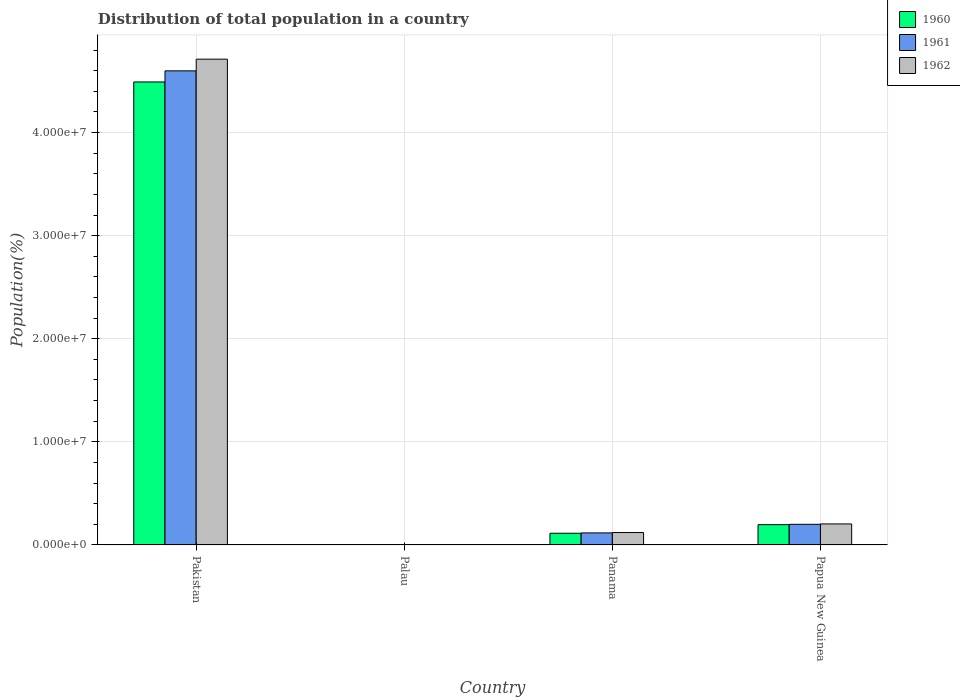Are the number of bars per tick equal to the number of legend labels?
Provide a succinct answer. Yes. What is the label of the 3rd group of bars from the left?
Keep it short and to the point. Panama. In how many cases, is the number of bars for a given country not equal to the number of legend labels?
Give a very brief answer. 0. What is the population of in 1961 in Pakistan?
Your answer should be very brief. 4.60e+07. Across all countries, what is the maximum population of in 1962?
Ensure brevity in your answer.  4.71e+07. Across all countries, what is the minimum population of in 1961?
Make the answer very short. 9901. In which country was the population of in 1961 maximum?
Give a very brief answer. Pakistan. In which country was the population of in 1960 minimum?
Your answer should be compact. Palau. What is the total population of in 1961 in the graph?
Make the answer very short. 4.92e+07. What is the difference between the population of in 1962 in Panama and that in Papua New Guinea?
Your answer should be very brief. -8.35e+05. What is the difference between the population of in 1960 in Palau and the population of in 1962 in Pakistan?
Your answer should be very brief. -4.71e+07. What is the average population of in 1960 per country?
Your response must be concise. 1.20e+07. What is the difference between the population of of/in 1960 and population of of/in 1961 in Panama?
Make the answer very short. -3.41e+04. In how many countries, is the population of in 1961 greater than 14000000 %?
Your response must be concise. 1. What is the ratio of the population of in 1960 in Panama to that in Papua New Guinea?
Your response must be concise. 0.58. Is the population of in 1960 in Pakistan less than that in Papua New Guinea?
Offer a terse response. No. What is the difference between the highest and the second highest population of in 1960?
Your answer should be compact. 4.38e+07. What is the difference between the highest and the lowest population of in 1962?
Offer a terse response. 4.71e+07. Is the sum of the population of in 1961 in Pakistan and Panama greater than the maximum population of in 1962 across all countries?
Your response must be concise. Yes. What does the 1st bar from the left in Panama represents?
Offer a terse response. 1960. What does the 3rd bar from the right in Pakistan represents?
Provide a succinct answer. 1960. Are the values on the major ticks of Y-axis written in scientific E-notation?
Provide a succinct answer. Yes. What is the title of the graph?
Your response must be concise. Distribution of total population in a country. Does "2007" appear as one of the legend labels in the graph?
Provide a short and direct response. No. What is the label or title of the X-axis?
Provide a short and direct response. Country. What is the label or title of the Y-axis?
Provide a succinct answer. Population(%). What is the Population(%) in 1960 in Pakistan?
Provide a short and direct response. 4.49e+07. What is the Population(%) of 1961 in Pakistan?
Ensure brevity in your answer.  4.60e+07. What is the Population(%) of 1962 in Pakistan?
Offer a very short reply. 4.71e+07. What is the Population(%) in 1960 in Palau?
Your response must be concise. 9638. What is the Population(%) of 1961 in Palau?
Ensure brevity in your answer.  9901. What is the Population(%) of 1962 in Palau?
Provide a succinct answer. 1.02e+04. What is the Population(%) in 1960 in Panama?
Offer a terse response. 1.13e+06. What is the Population(%) in 1961 in Panama?
Provide a succinct answer. 1.17e+06. What is the Population(%) in 1962 in Panama?
Make the answer very short. 1.20e+06. What is the Population(%) in 1960 in Papua New Guinea?
Ensure brevity in your answer.  1.97e+06. What is the Population(%) of 1961 in Papua New Guinea?
Provide a succinct answer. 2.00e+06. What is the Population(%) of 1962 in Papua New Guinea?
Provide a short and direct response. 2.04e+06. Across all countries, what is the maximum Population(%) in 1960?
Provide a succinct answer. 4.49e+07. Across all countries, what is the maximum Population(%) of 1961?
Offer a very short reply. 4.60e+07. Across all countries, what is the maximum Population(%) of 1962?
Provide a succinct answer. 4.71e+07. Across all countries, what is the minimum Population(%) in 1960?
Your answer should be compact. 9638. Across all countries, what is the minimum Population(%) of 1961?
Your answer should be very brief. 9901. Across all countries, what is the minimum Population(%) in 1962?
Ensure brevity in your answer.  1.02e+04. What is the total Population(%) of 1960 in the graph?
Give a very brief answer. 4.80e+07. What is the total Population(%) of 1961 in the graph?
Your answer should be very brief. 4.92e+07. What is the total Population(%) of 1962 in the graph?
Keep it short and to the point. 5.04e+07. What is the difference between the Population(%) in 1960 in Pakistan and that in Palau?
Offer a very short reply. 4.49e+07. What is the difference between the Population(%) of 1961 in Pakistan and that in Palau?
Your answer should be very brief. 4.60e+07. What is the difference between the Population(%) of 1962 in Pakistan and that in Palau?
Make the answer very short. 4.71e+07. What is the difference between the Population(%) of 1960 in Pakistan and that in Panama?
Offer a very short reply. 4.38e+07. What is the difference between the Population(%) of 1961 in Pakistan and that in Panama?
Make the answer very short. 4.48e+07. What is the difference between the Population(%) of 1962 in Pakistan and that in Panama?
Provide a succinct answer. 4.59e+07. What is the difference between the Population(%) in 1960 in Pakistan and that in Papua New Guinea?
Provide a succinct answer. 4.29e+07. What is the difference between the Population(%) in 1961 in Pakistan and that in Papua New Guinea?
Provide a short and direct response. 4.40e+07. What is the difference between the Population(%) in 1962 in Pakistan and that in Papua New Guinea?
Offer a very short reply. 4.51e+07. What is the difference between the Population(%) in 1960 in Palau and that in Panama?
Offer a terse response. -1.12e+06. What is the difference between the Population(%) of 1961 in Palau and that in Panama?
Provide a short and direct response. -1.16e+06. What is the difference between the Population(%) in 1962 in Palau and that in Panama?
Provide a short and direct response. -1.19e+06. What is the difference between the Population(%) of 1960 in Palau and that in Papua New Guinea?
Offer a very short reply. -1.96e+06. What is the difference between the Population(%) in 1961 in Palau and that in Papua New Guinea?
Provide a succinct answer. -1.99e+06. What is the difference between the Population(%) of 1962 in Palau and that in Papua New Guinea?
Your answer should be compact. -2.03e+06. What is the difference between the Population(%) in 1960 in Panama and that in Papua New Guinea?
Offer a terse response. -8.34e+05. What is the difference between the Population(%) of 1961 in Panama and that in Papua New Guinea?
Offer a very short reply. -8.34e+05. What is the difference between the Population(%) in 1962 in Panama and that in Papua New Guinea?
Provide a short and direct response. -8.35e+05. What is the difference between the Population(%) of 1960 in Pakistan and the Population(%) of 1961 in Palau?
Your answer should be very brief. 4.49e+07. What is the difference between the Population(%) of 1960 in Pakistan and the Population(%) of 1962 in Palau?
Offer a terse response. 4.49e+07. What is the difference between the Population(%) in 1961 in Pakistan and the Population(%) in 1962 in Palau?
Make the answer very short. 4.60e+07. What is the difference between the Population(%) in 1960 in Pakistan and the Population(%) in 1961 in Panama?
Offer a terse response. 4.37e+07. What is the difference between the Population(%) in 1960 in Pakistan and the Population(%) in 1962 in Panama?
Provide a succinct answer. 4.37e+07. What is the difference between the Population(%) in 1961 in Pakistan and the Population(%) in 1962 in Panama?
Provide a succinct answer. 4.48e+07. What is the difference between the Population(%) in 1960 in Pakistan and the Population(%) in 1961 in Papua New Guinea?
Your response must be concise. 4.29e+07. What is the difference between the Population(%) in 1960 in Pakistan and the Population(%) in 1962 in Papua New Guinea?
Offer a terse response. 4.29e+07. What is the difference between the Population(%) of 1961 in Pakistan and the Population(%) of 1962 in Papua New Guinea?
Keep it short and to the point. 4.40e+07. What is the difference between the Population(%) of 1960 in Palau and the Population(%) of 1961 in Panama?
Your answer should be very brief. -1.16e+06. What is the difference between the Population(%) in 1960 in Palau and the Population(%) in 1962 in Panama?
Offer a very short reply. -1.19e+06. What is the difference between the Population(%) of 1961 in Palau and the Population(%) of 1962 in Panama?
Offer a terse response. -1.19e+06. What is the difference between the Population(%) of 1960 in Palau and the Population(%) of 1961 in Papua New Guinea?
Your answer should be very brief. -1.99e+06. What is the difference between the Population(%) in 1960 in Palau and the Population(%) in 1962 in Papua New Guinea?
Offer a terse response. -2.03e+06. What is the difference between the Population(%) of 1961 in Palau and the Population(%) of 1962 in Papua New Guinea?
Your answer should be compact. -2.03e+06. What is the difference between the Population(%) in 1960 in Panama and the Population(%) in 1961 in Papua New Guinea?
Ensure brevity in your answer.  -8.68e+05. What is the difference between the Population(%) in 1960 in Panama and the Population(%) in 1962 in Papua New Guinea?
Keep it short and to the point. -9.04e+05. What is the difference between the Population(%) in 1961 in Panama and the Population(%) in 1962 in Papua New Guinea?
Make the answer very short. -8.70e+05. What is the average Population(%) in 1960 per country?
Your answer should be compact. 1.20e+07. What is the average Population(%) of 1961 per country?
Offer a very short reply. 1.23e+07. What is the average Population(%) in 1962 per country?
Provide a succinct answer. 1.26e+07. What is the difference between the Population(%) in 1960 and Population(%) in 1961 in Pakistan?
Offer a very short reply. -1.08e+06. What is the difference between the Population(%) of 1960 and Population(%) of 1962 in Pakistan?
Provide a short and direct response. -2.21e+06. What is the difference between the Population(%) in 1961 and Population(%) in 1962 in Pakistan?
Keep it short and to the point. -1.13e+06. What is the difference between the Population(%) of 1960 and Population(%) of 1961 in Palau?
Your answer should be very brief. -263. What is the difference between the Population(%) of 1960 and Population(%) of 1962 in Palau?
Your answer should be compact. -512. What is the difference between the Population(%) of 1961 and Population(%) of 1962 in Palau?
Make the answer very short. -249. What is the difference between the Population(%) in 1960 and Population(%) in 1961 in Panama?
Offer a very short reply. -3.41e+04. What is the difference between the Population(%) in 1960 and Population(%) in 1962 in Panama?
Provide a short and direct response. -6.94e+04. What is the difference between the Population(%) of 1961 and Population(%) of 1962 in Panama?
Your answer should be compact. -3.53e+04. What is the difference between the Population(%) in 1960 and Population(%) in 1961 in Papua New Guinea?
Ensure brevity in your answer.  -3.41e+04. What is the difference between the Population(%) in 1960 and Population(%) in 1962 in Papua New Guinea?
Ensure brevity in your answer.  -7.02e+04. What is the difference between the Population(%) of 1961 and Population(%) of 1962 in Papua New Guinea?
Provide a short and direct response. -3.61e+04. What is the ratio of the Population(%) of 1960 in Pakistan to that in Palau?
Keep it short and to the point. 4659.87. What is the ratio of the Population(%) in 1961 in Pakistan to that in Palau?
Ensure brevity in your answer.  4644.83. What is the ratio of the Population(%) of 1962 in Pakistan to that in Palau?
Offer a very short reply. 4642.65. What is the ratio of the Population(%) of 1960 in Pakistan to that in Panama?
Keep it short and to the point. 39.64. What is the ratio of the Population(%) in 1961 in Pakistan to that in Panama?
Provide a succinct answer. 39.41. What is the ratio of the Population(%) of 1962 in Pakistan to that in Panama?
Provide a short and direct response. 39.19. What is the ratio of the Population(%) of 1960 in Pakistan to that in Papua New Guinea?
Your answer should be very brief. 22.83. What is the ratio of the Population(%) of 1961 in Pakistan to that in Papua New Guinea?
Provide a succinct answer. 22.98. What is the ratio of the Population(%) of 1962 in Pakistan to that in Papua New Guinea?
Your answer should be very brief. 23.13. What is the ratio of the Population(%) of 1960 in Palau to that in Panama?
Keep it short and to the point. 0.01. What is the ratio of the Population(%) of 1961 in Palau to that in Panama?
Provide a succinct answer. 0.01. What is the ratio of the Population(%) in 1962 in Palau to that in Panama?
Make the answer very short. 0.01. What is the ratio of the Population(%) in 1960 in Palau to that in Papua New Guinea?
Offer a terse response. 0. What is the ratio of the Population(%) in 1961 in Palau to that in Papua New Guinea?
Your response must be concise. 0. What is the ratio of the Population(%) in 1962 in Palau to that in Papua New Guinea?
Provide a short and direct response. 0.01. What is the ratio of the Population(%) of 1960 in Panama to that in Papua New Guinea?
Keep it short and to the point. 0.58. What is the ratio of the Population(%) in 1961 in Panama to that in Papua New Guinea?
Your answer should be very brief. 0.58. What is the ratio of the Population(%) in 1962 in Panama to that in Papua New Guinea?
Give a very brief answer. 0.59. What is the difference between the highest and the second highest Population(%) in 1960?
Your answer should be compact. 4.29e+07. What is the difference between the highest and the second highest Population(%) of 1961?
Your answer should be compact. 4.40e+07. What is the difference between the highest and the second highest Population(%) of 1962?
Provide a short and direct response. 4.51e+07. What is the difference between the highest and the lowest Population(%) in 1960?
Ensure brevity in your answer.  4.49e+07. What is the difference between the highest and the lowest Population(%) in 1961?
Your answer should be compact. 4.60e+07. What is the difference between the highest and the lowest Population(%) of 1962?
Ensure brevity in your answer.  4.71e+07. 